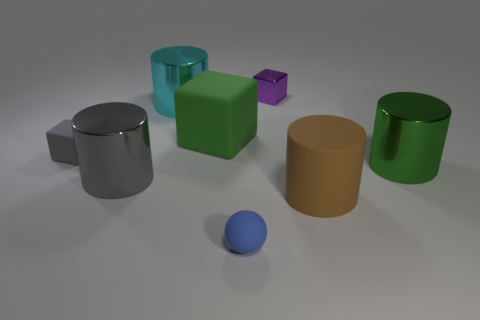Is the number of big shiny cylinders that are in front of the big cyan metallic object less than the number of tiny metallic blocks to the right of the purple cube?
Offer a very short reply. No. What number of tiny purple things have the same material as the big gray object?
Your answer should be very brief. 1. There is a shiny cylinder behind the shiny thing that is right of the purple block; are there any gray rubber blocks that are behind it?
Your response must be concise. No. How many cylinders are big cyan metal things or green things?
Your response must be concise. 2. There is a large gray object; is its shape the same as the big matte thing that is in front of the green shiny object?
Your answer should be very brief. Yes. Are there fewer small gray matte blocks that are in front of the brown thing than red rubber cylinders?
Provide a succinct answer. No. There is a large green metallic cylinder; are there any large matte cubes on the left side of it?
Your response must be concise. Yes. Is there a big metal object of the same shape as the large green matte object?
Your response must be concise. No. There is a rubber thing that is the same size as the blue rubber sphere; what shape is it?
Your response must be concise. Cube. What number of objects are big shiny things that are left of the cyan metal thing or shiny cylinders?
Make the answer very short. 3. 